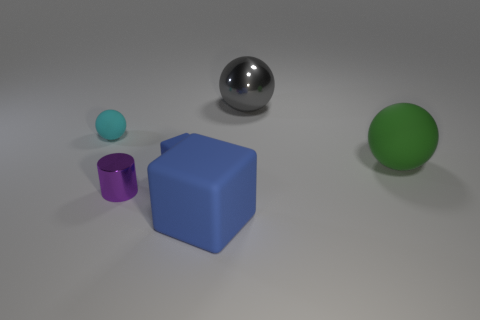Add 1 big green balls. How many objects exist? 7 Subtract all cylinders. How many objects are left? 5 Add 1 shiny cylinders. How many shiny cylinders exist? 2 Subtract 0 cyan cylinders. How many objects are left? 6 Subtract all large matte things. Subtract all big green objects. How many objects are left? 3 Add 4 big metal objects. How many big metal objects are left? 5 